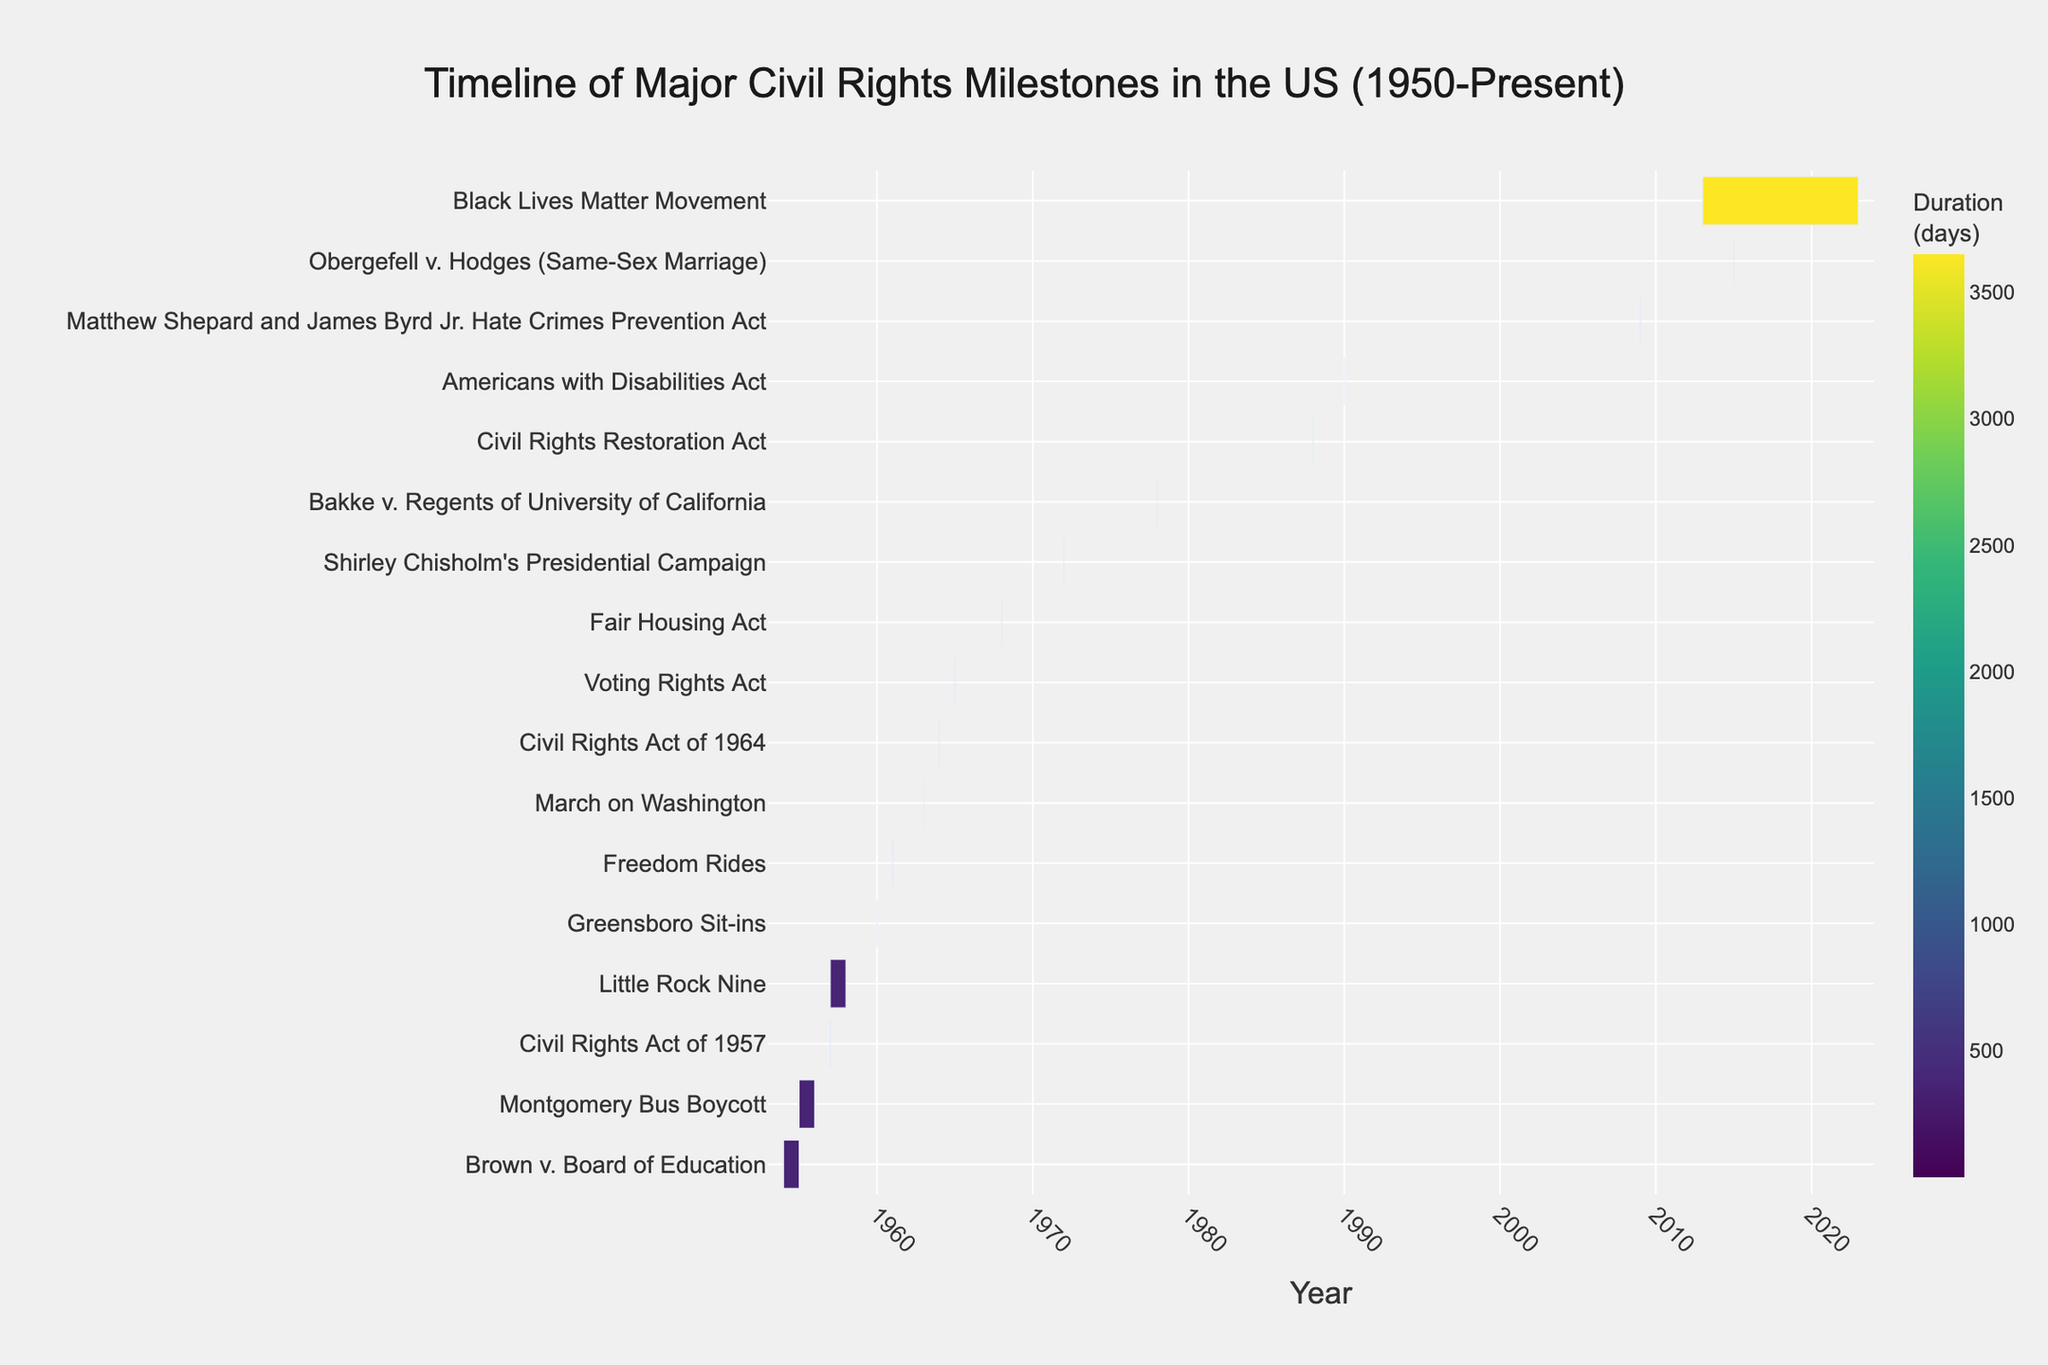What is the title of the chart? The title is displayed prominently at the top center of the chart. It provides an overall description of what the chart represents.
Answer: Timeline of Major Civil Rights Milestones in the US (1950-Present) Between which years did the Black Lives Matter Movement occur according to the chart? The chart plots events along a timeline with their corresponding start and end years. For the Black Lives Matter Movement, locate the event on the y-axis and read off the x-axis values for start and end.
Answer: 2013-2023 Which event has the longest duration according to the chart? Duration is represented by the length of the bars. Identify the bar that spans the longest distance horizontally.
Answer: Black Lives Matter Movement What is the shortest duration event listed on the chart? Look for events with very short horizontal bars. Events that start and end within the same year will have the shortest bars.
Answer: Civil Rights Act of 1957 How many events occurred between 1950 and 1960? Count the number of bars that fall within the range 1950 to 1960 on the x-axis.
Answer: 5 Which event occurred most recently according to the chart? Find the bar that extends furthest to the right on the x-axis since it indicates the most recent end date.
Answer: Black Lives Matter Movement Which events concluded in the same year they started? Identify horizontal bars that span only a single year, meaning their start and end dates are the same.
Answer: Civil Rights Act of 1957, Greensboro Sit-ins, Freedom Rides, March on Washington, Civil Rights Act of 1964, Voting Rights Act, Fair Housing Act, Shirley Chisholm's Presidential Campaign, Bakke v. Regents of University of California, Civil Rights Restoration Act, Americans with Disabilities Act, Matthew Shepard and James Byrd Jr. Hate Crimes Prevention Act, Obergefell v. Hodges (Same-Sex Marriage) How many events have a duration of more than one year? Count the number of bars that span more than one year on the x-axis.
Answer: 4 What significant milestone in the timeline happened directly after the Brown v. Board of Education case? Look for the event listed immediately after Brown v. Board of Education by tracking the order along the y-axis.
Answer: Montgomery Bus Boycott 